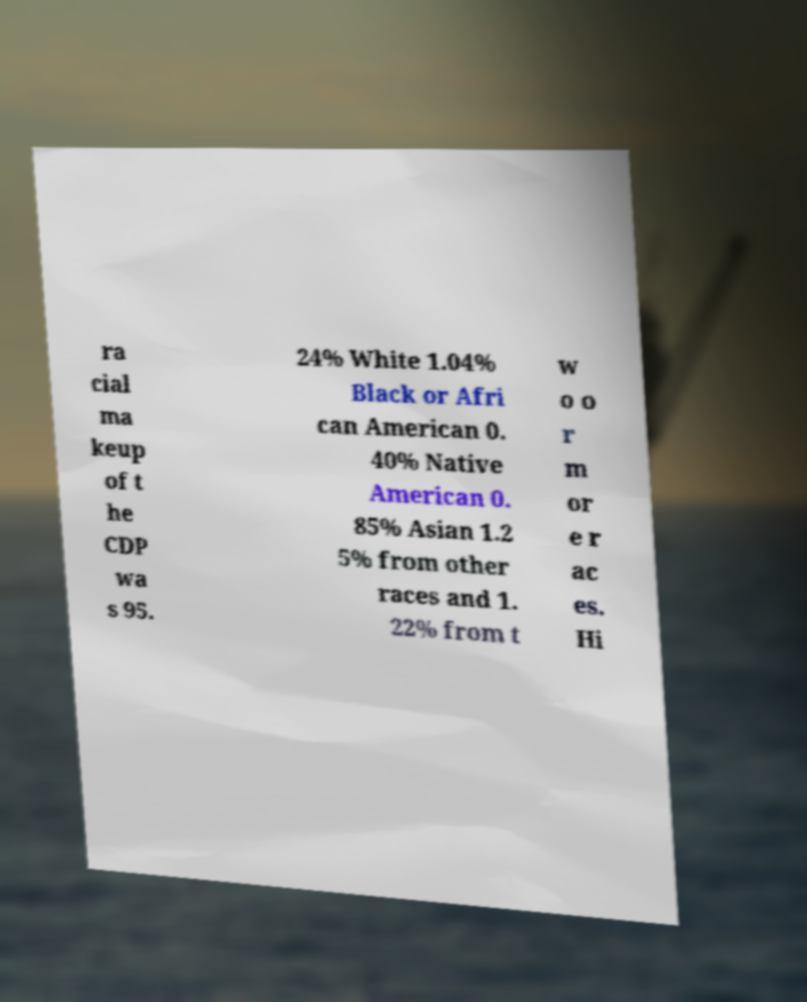What messages or text are displayed in this image? I need them in a readable, typed format. ra cial ma keup of t he CDP wa s 95. 24% White 1.04% Black or Afri can American 0. 40% Native American 0. 85% Asian 1.2 5% from other races and 1. 22% from t w o o r m or e r ac es. Hi 